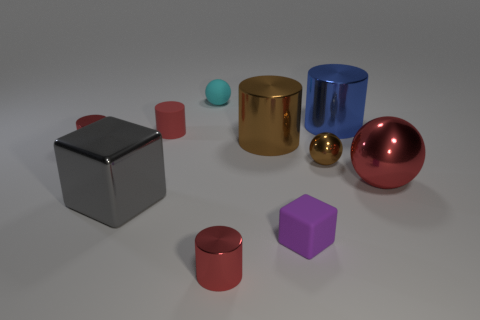Can you tell which objects might weigh the most and the least? Based on the image, the gold-colored cylinder likely weighs the most due to its size and the material it appears to be made of, which looks like a dense metal. Conversely, the small blue sphere might weigh the least, given its relative size and the material it appears to be made of, which might be a light plastic. 